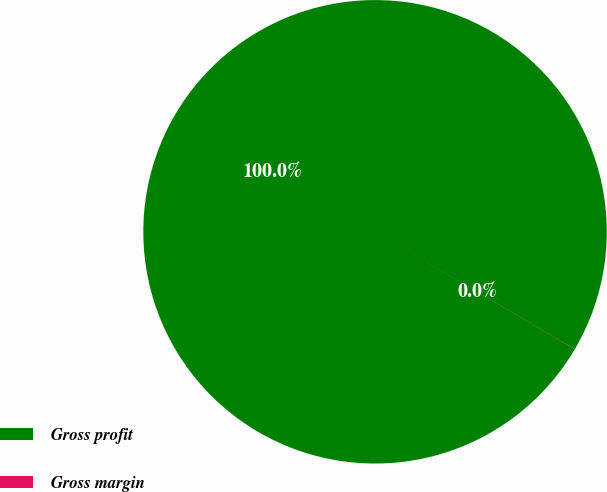Convert chart. <chart><loc_0><loc_0><loc_500><loc_500><pie_chart><fcel>Gross profit<fcel>Gross margin<nl><fcel>99.99%<fcel>0.01%<nl></chart> 